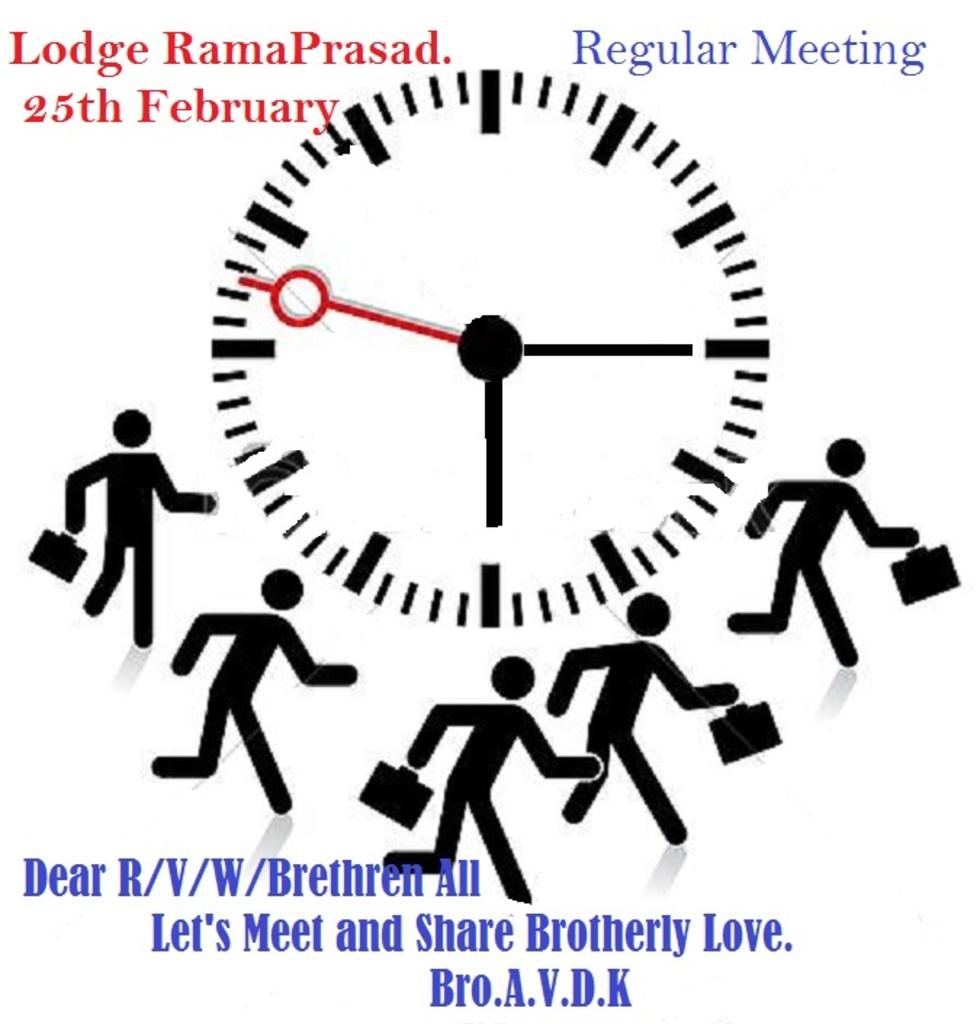<image>
Create a compact narrative representing the image presented. A regular meeting of Ladoge RamaPrasad will be held February 25th. 